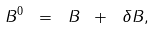<formula> <loc_0><loc_0><loc_500><loc_500>B ^ { 0 } \ = \ B \ + \ \delta B ,</formula> 